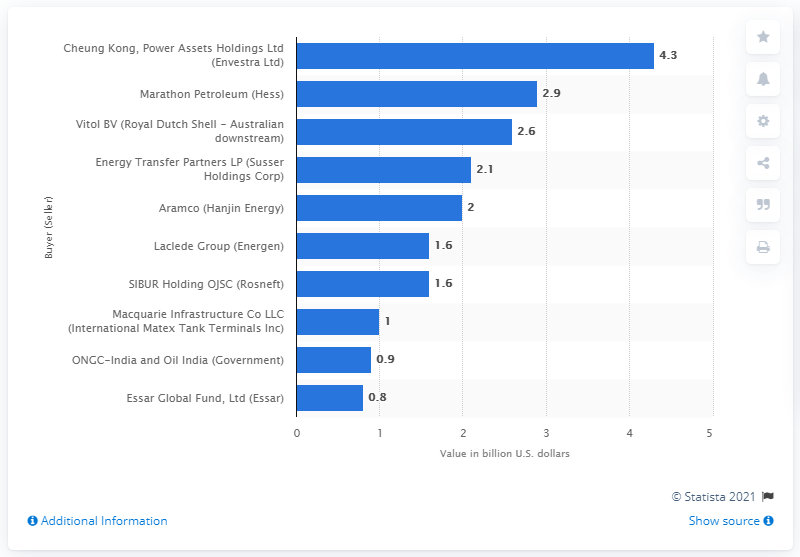Give some essential details in this illustration. According to the information, Vitol BV spent 2.6... on Royal Dutch Shell's Australian downstream business. 